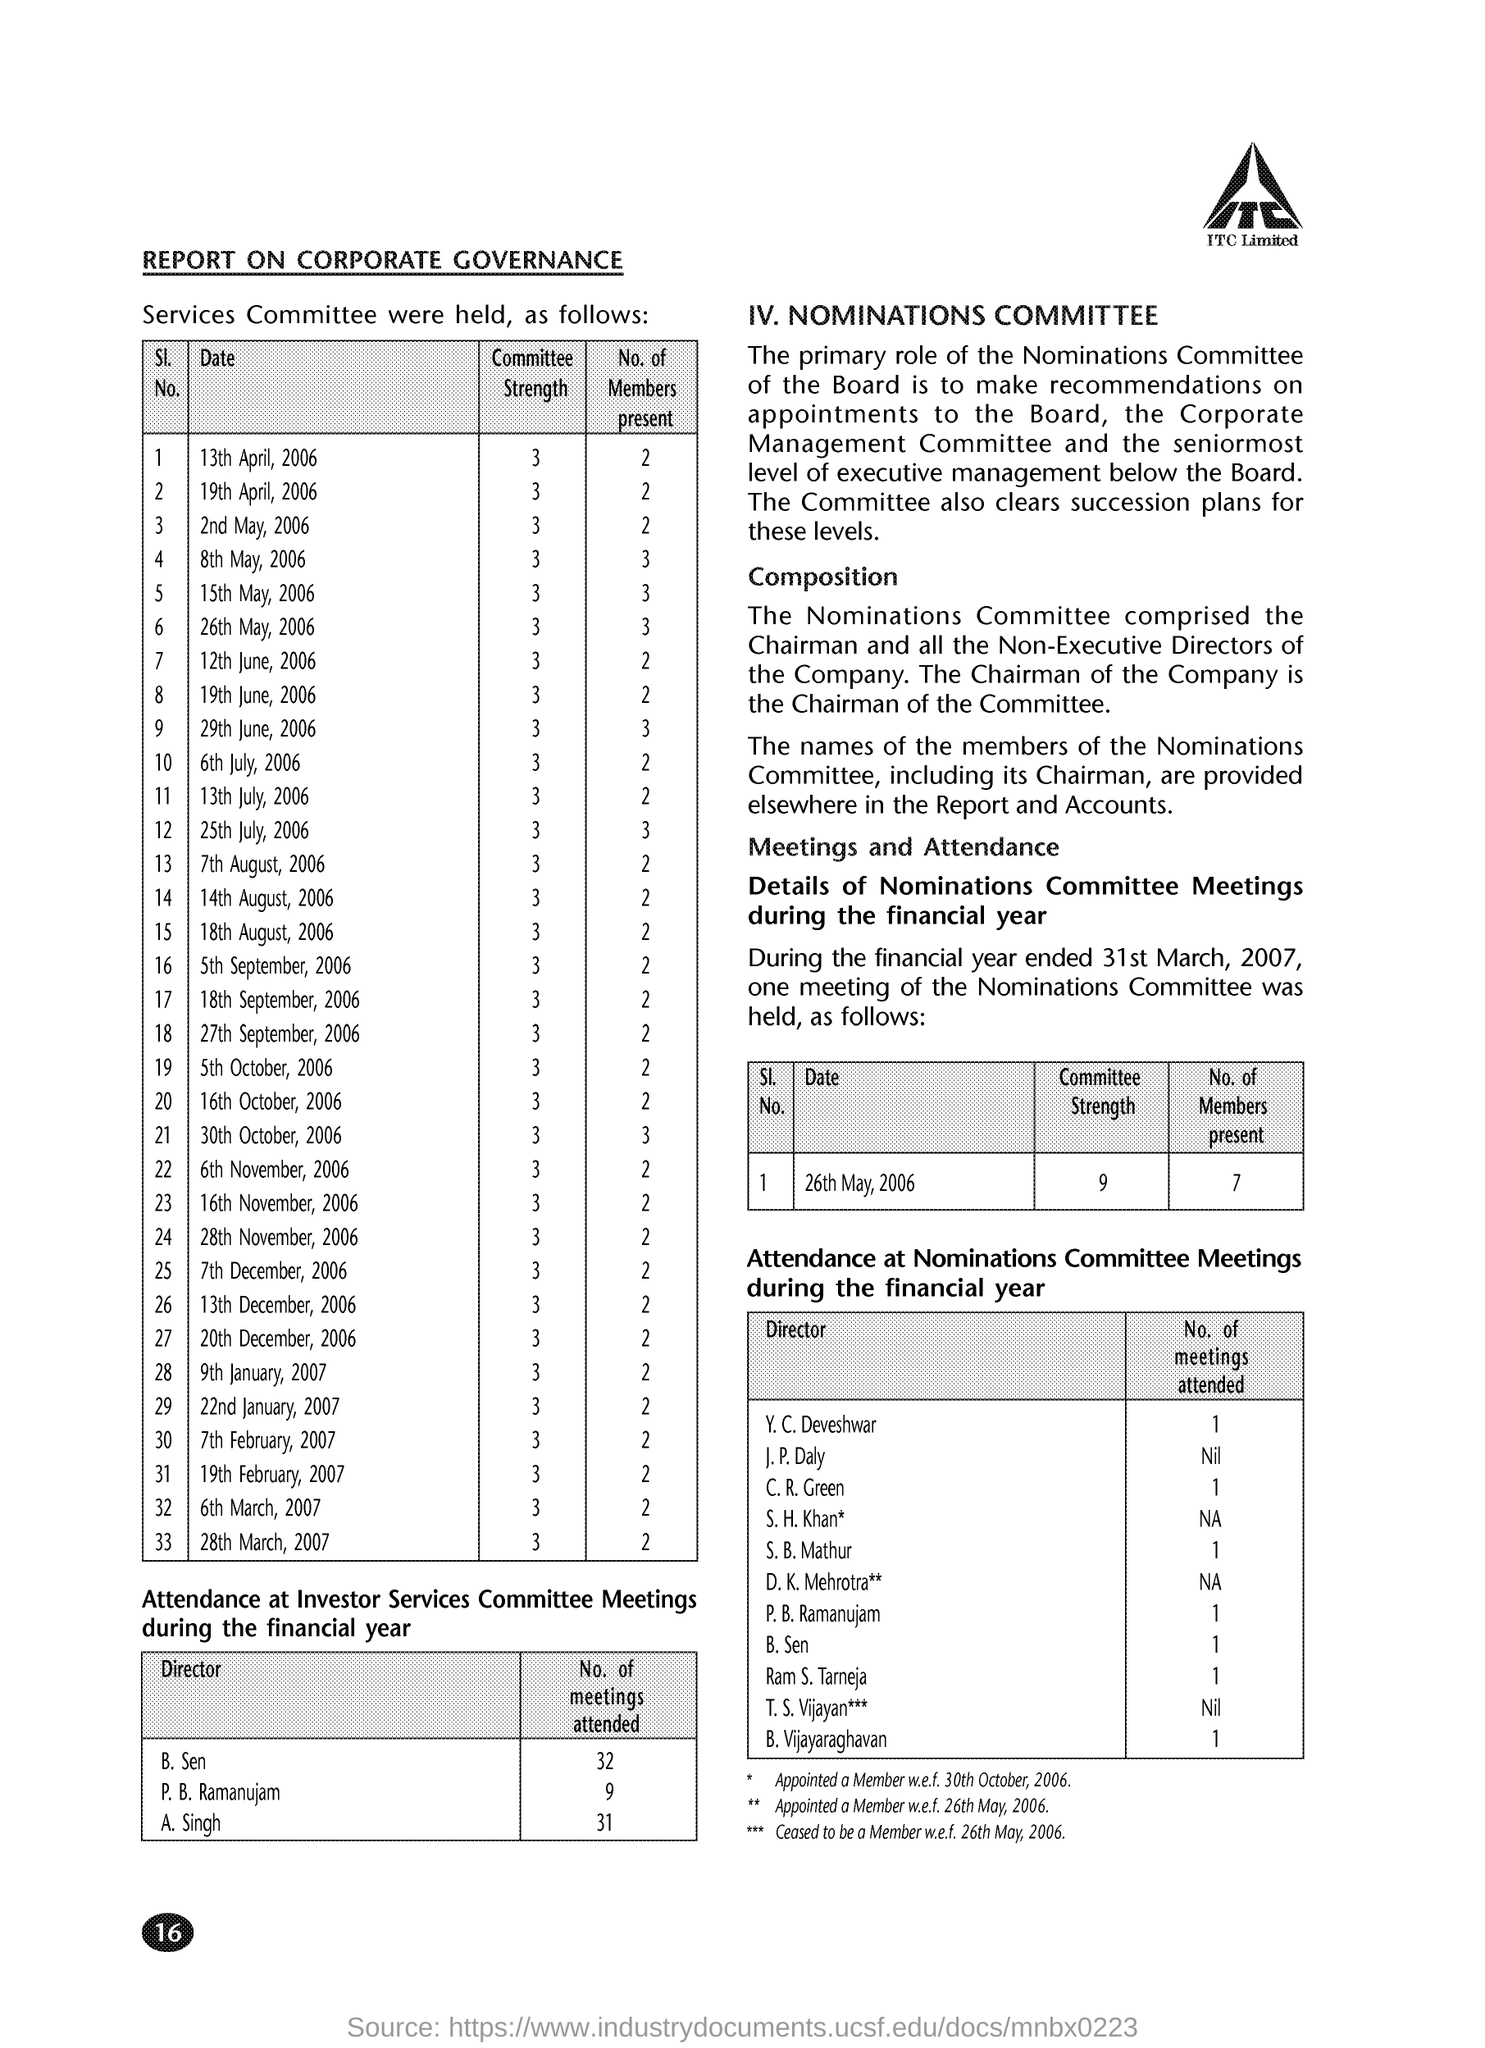What is the Committee Strength for 13th April, 2006?
Offer a terse response. 3. What is the Committee Strength for 19th April, 2006?
Your answer should be compact. 3. What is the Committee Strength for 15th May, 2006?
Give a very brief answer. 3. What is the Committee Strength for 6th July, 2006?
Offer a very short reply. 3. What is the No. of Members present for 13th April, 2006?
Offer a terse response. 2. What is the No. of Members present for 13th July, 2006?
Keep it short and to the point. 2. What is the No. of Members present for 16th October, 2006?
Make the answer very short. 2. 